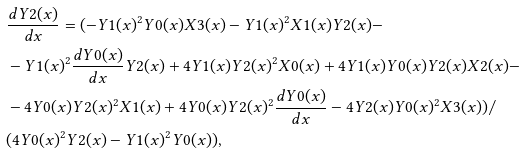<formula> <loc_0><loc_0><loc_500><loc_500>& \frac { d Y 2 ( x ) } { d x } = ( - Y 1 ( x ) ^ { 2 } Y 0 ( x ) X 3 ( x ) - Y 1 ( x ) ^ { 2 } X 1 ( x ) Y 2 ( x ) - \\ & - Y 1 ( x ) ^ { 2 } \frac { d Y 0 ( x ) } { d x } Y 2 ( x ) + 4 Y 1 ( x ) Y 2 ( x ) ^ { 2 } X 0 ( x ) + 4 Y 1 ( x ) Y 0 ( x ) Y 2 ( x ) X 2 ( x ) - \\ & - 4 Y 0 ( x ) Y 2 ( x ) ^ { 2 } X 1 ( x ) + 4 Y 0 ( x ) Y 2 ( x ) ^ { 2 } \frac { d Y 0 ( x ) } { d x } - 4 Y 2 ( x ) Y 0 ( x ) ^ { 2 } X 3 ( x ) ) / \\ & ( 4 Y 0 ( x ) ^ { 2 } Y 2 ( x ) - Y 1 ( x ) ^ { 2 } Y 0 ( x ) ) ,</formula> 